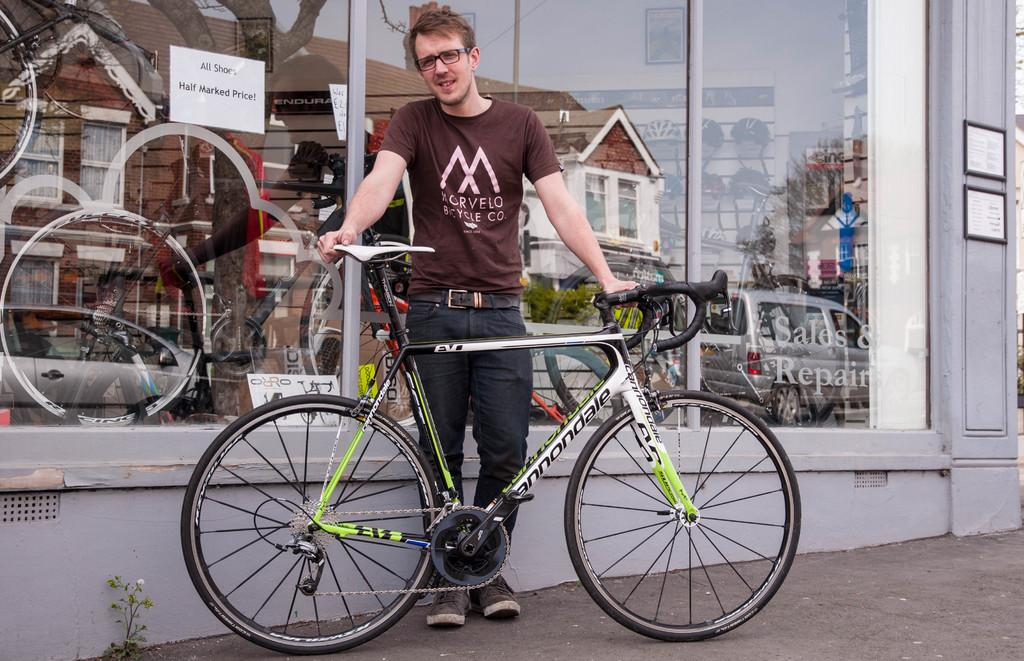Who or what is present in the image? There is a person in the image. What object is also visible in the image? There is a bicycle in the image. What can be seen in the background of the image? There is a window in the background of the image, through which vehicles and buildings are visible. What type of reaction can be seen on the person's feet in the image? There is no mention of the person's feet or any reaction in the image, as the facts provided only mention the person, the bicycle, and the window with a view of vehicles and buildings. 